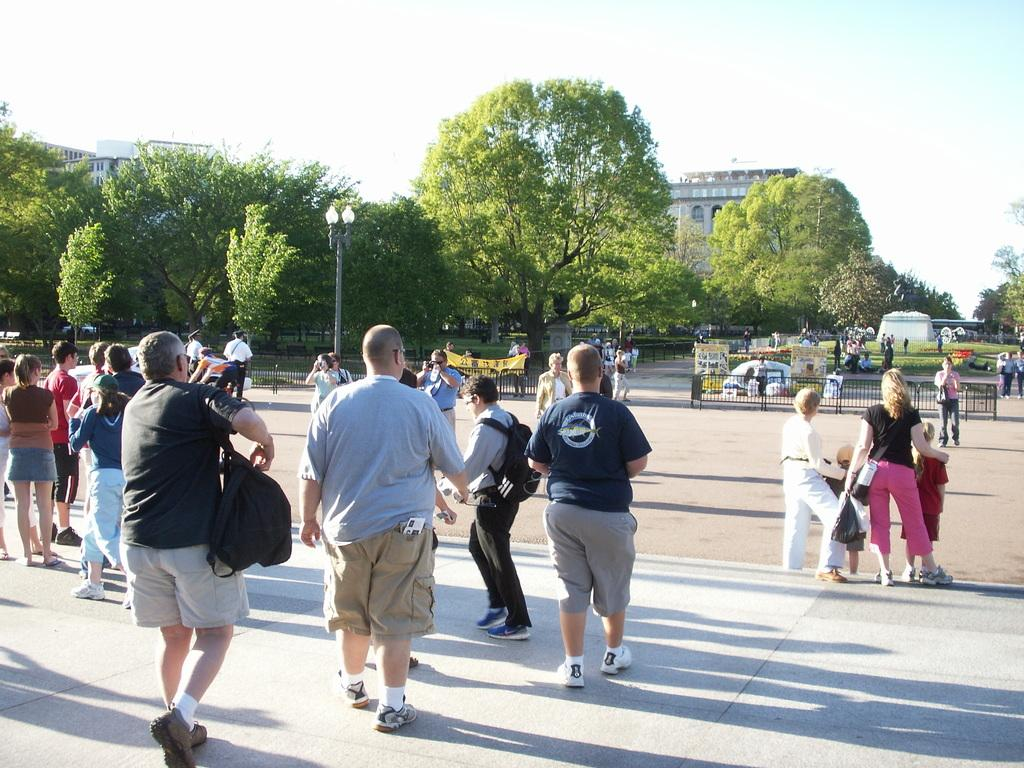What are the people in the image doing? There are people standing and walking in the image. What type of natural elements can be seen in the image? There are trees in the image. What type of man-made structures are present in the image? There are buildings in the image. What is visible in the background of the image? The sky is visible in the image. What type of cracker is being used as a prop in the image? There is no cracker present in the image. What is the interest rate for the loan depicted in the image? There is no loan or interest rate mentioned in the image. 